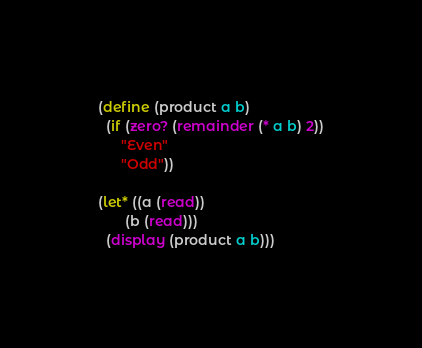<code> <loc_0><loc_0><loc_500><loc_500><_Scheme_>(define (product a b)
  (if (zero? (remainder (* a b) 2))
      "Even"
      "Odd"))

(let* ((a (read))
       (b (read)))
  (display (product a b)))</code> 